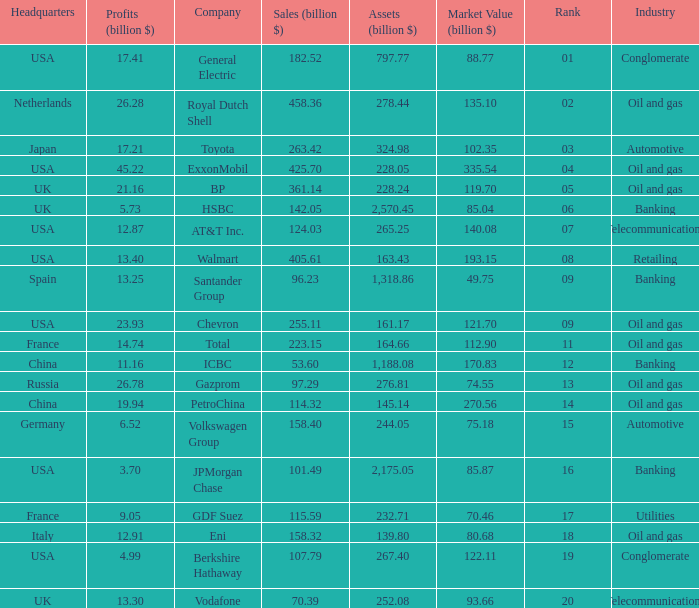Name the Sales (billion $) which have a Company of exxonmobil? 425.7. 